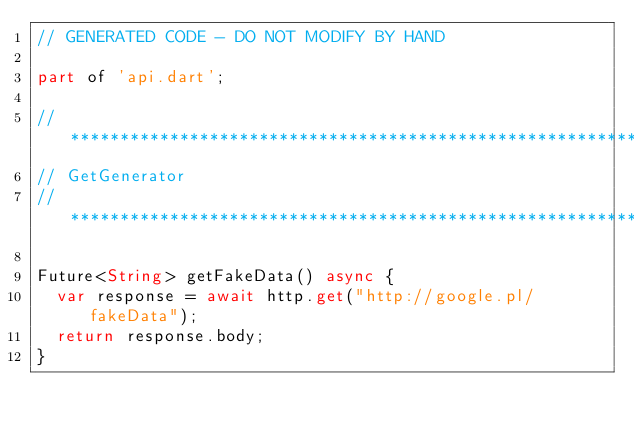Convert code to text. <code><loc_0><loc_0><loc_500><loc_500><_Dart_>// GENERATED CODE - DO NOT MODIFY BY HAND

part of 'api.dart';

// **************************************************************************
// GetGenerator
// **************************************************************************

Future<String> getFakeData() async {
  var response = await http.get("http://google.pl/fakeData");
  return response.body;
}
</code> 